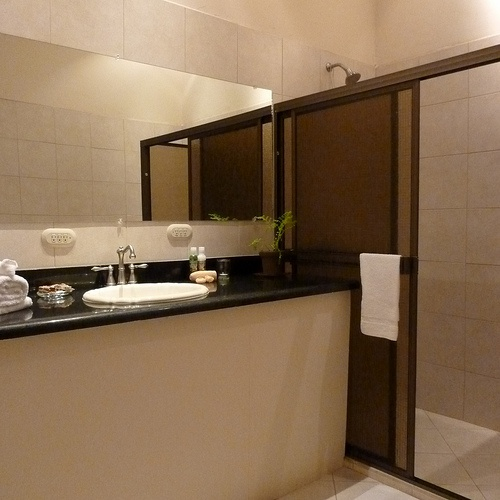Describe the objects in this image and their specific colors. I can see sink in tan, beige, black, and gray tones, potted plant in tan, black, olive, and gray tones, bottle in tan, olive, and black tones, and bottle in tan and beige tones in this image. 